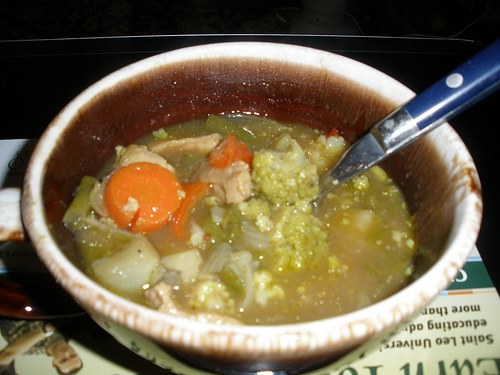What is the ultimate goal of having vegetables in the soup scene? The ultimate goal of having vegetables in the soup is to create a balanced and nutritious meal. Vegetables provide essential vitamins, minerals, and fibers that contribute to overall health. They add a range of flavors, textures, and colors, making the soup more vibrant and satisfying. Additionally, incorporating a variety of vegetables ensures a diverse nutrient profile, which can support immune health, digestion, and overall wellbeing. 